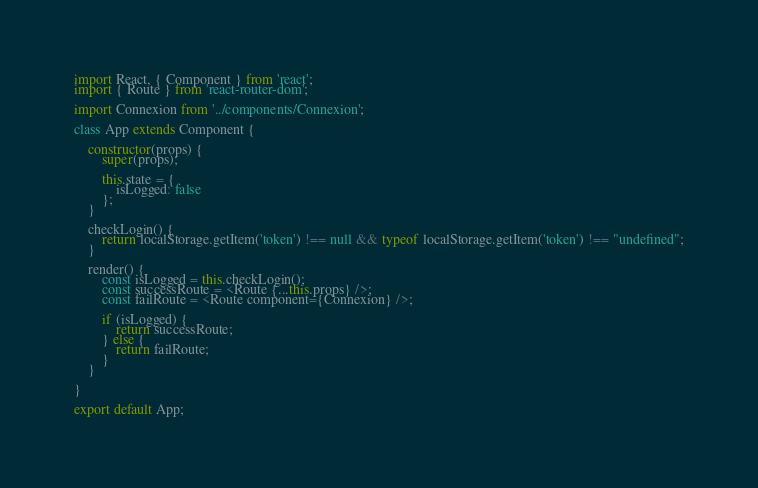<code> <loc_0><loc_0><loc_500><loc_500><_JavaScript_>import React, { Component } from 'react';
import { Route } from 'react-router-dom';

import Connexion from '../components/Connexion';

class App extends Component {

    constructor(props) {
        super(props);

        this.state = {
            isLogged: false
        };
    }

    checkLogin() {
        return localStorage.getItem('token') !== null && typeof localStorage.getItem('token') !== "undefined";
    }

    render() {
        const isLogged = this.checkLogin();
        const successRoute = <Route {...this.props} />;
        const failRoute = <Route component={Connexion} />;

        if (isLogged) {
            return successRoute;
        } else {
            return failRoute;
        }
    }

}

export default App;
</code> 